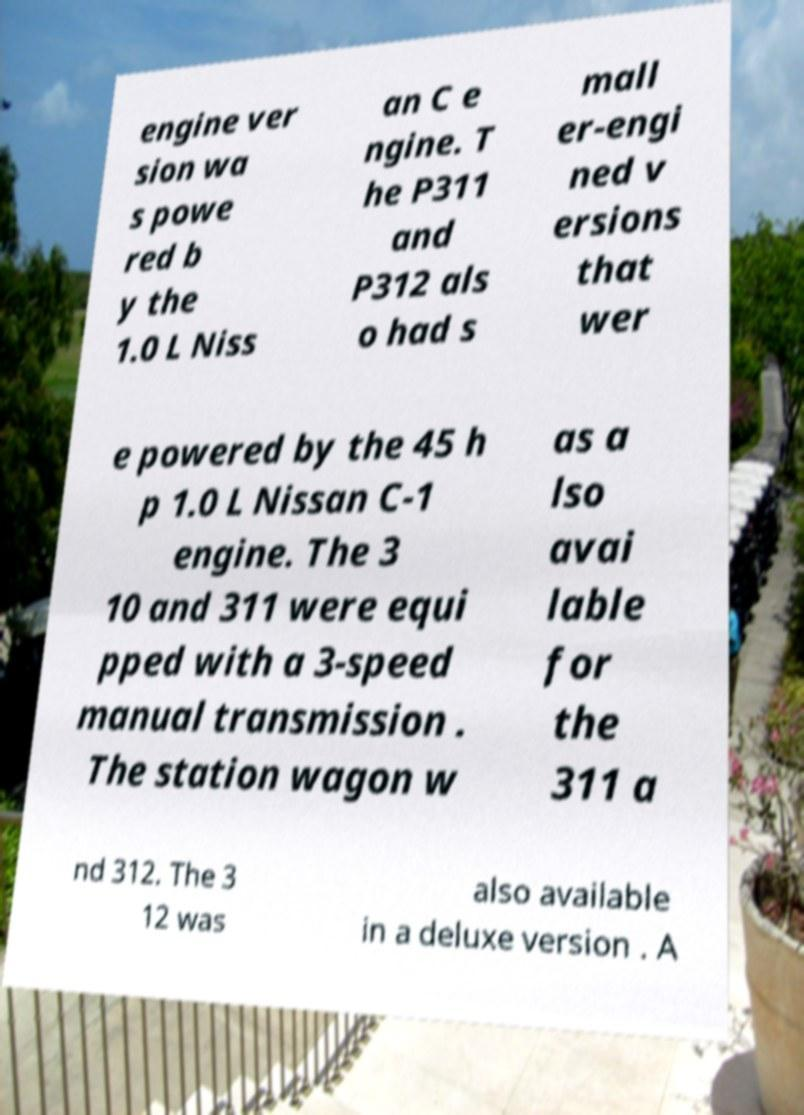Could you extract and type out the text from this image? engine ver sion wa s powe red b y the 1.0 L Niss an C e ngine. T he P311 and P312 als o had s mall er-engi ned v ersions that wer e powered by the 45 h p 1.0 L Nissan C-1 engine. The 3 10 and 311 were equi pped with a 3-speed manual transmission . The station wagon w as a lso avai lable for the 311 a nd 312. The 3 12 was also available in a deluxe version . A 